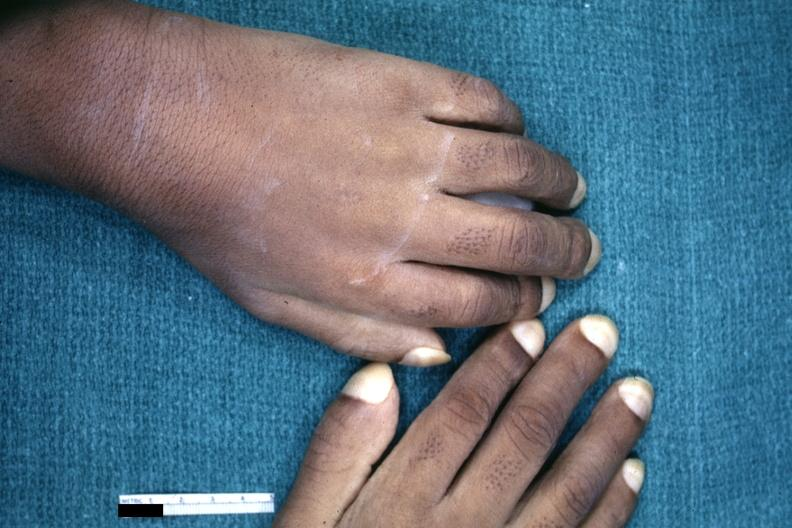what are present?
Answer the question using a single word or phrase. Extremities 